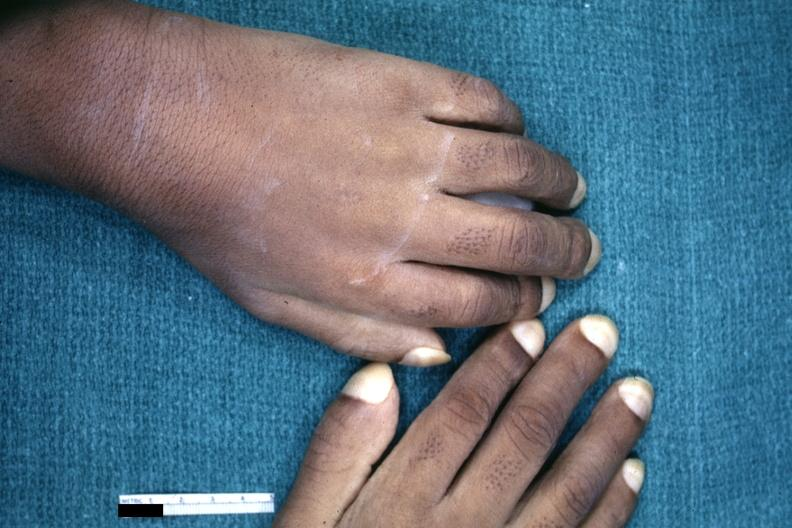what are present?
Answer the question using a single word or phrase. Extremities 